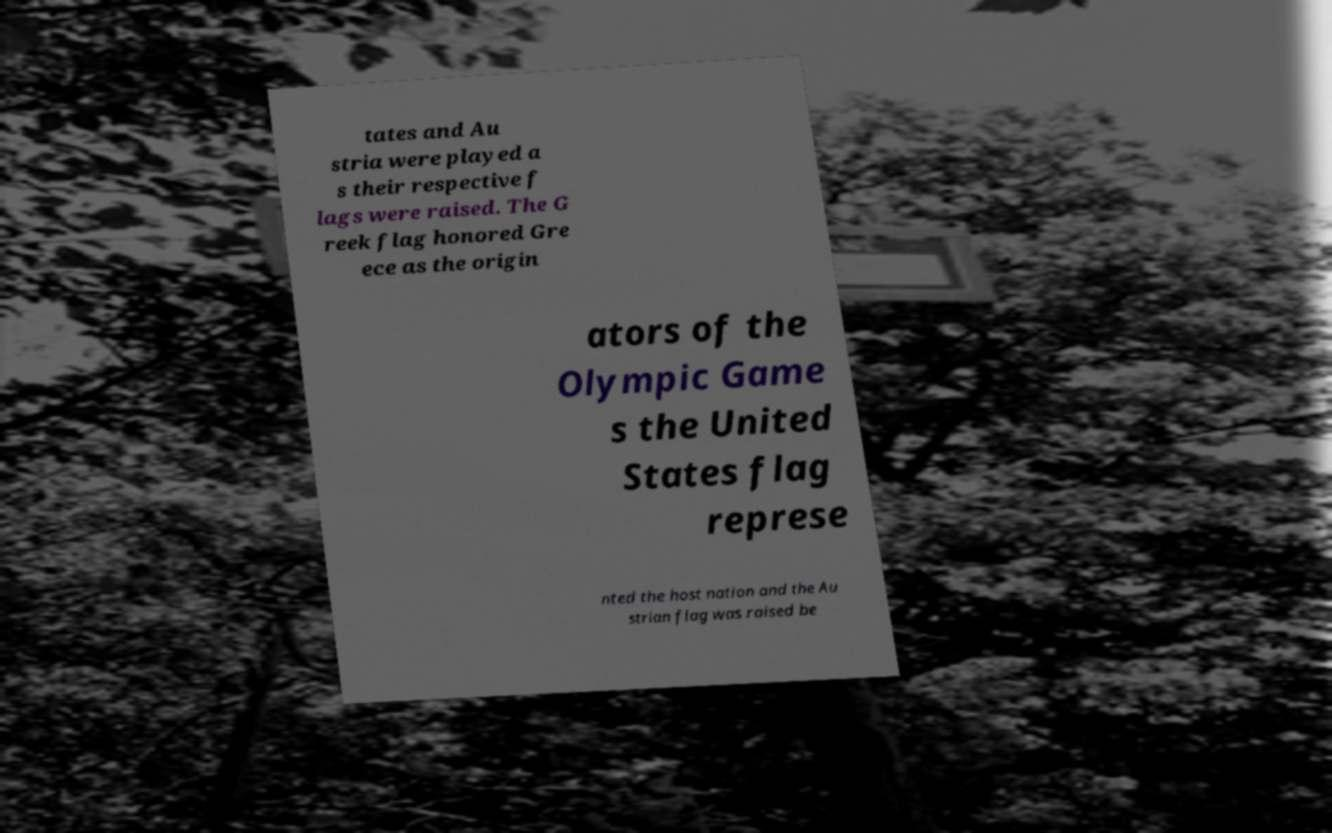Please read and relay the text visible in this image. What does it say? tates and Au stria were played a s their respective f lags were raised. The G reek flag honored Gre ece as the origin ators of the Olympic Game s the United States flag represe nted the host nation and the Au strian flag was raised be 